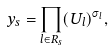Convert formula to latex. <formula><loc_0><loc_0><loc_500><loc_500>y _ { s } = \prod _ { l \in R _ { s } } ( U _ { l } ) ^ { \sigma _ { l } } ,</formula> 